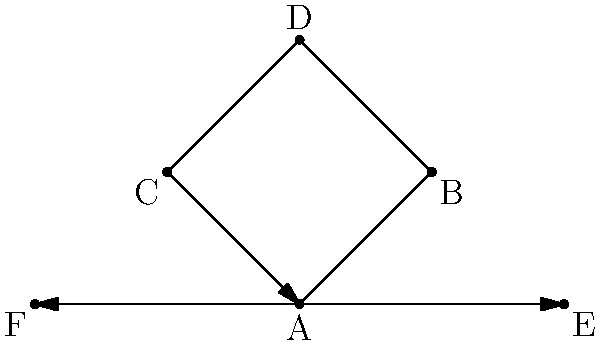After a merger between two companies, the new organizational structure is represented by the Cayley graph shown above. If the generating set consists of three operations (promotion, lateral transfer, and demotion), what is the order of the group represented by this Cayley graph? To determine the order of the group represented by this Cayley graph, we need to follow these steps:

1. Identify the number of vertices: The graph has 6 vertices (A, B, C, D, E, and F).

2. Understand the Cayley graph properties:
   - Each vertex represents an element of the group.
   - Each edge represents the action of a generator on a group element.

3. Analyze the graph structure:
   - The graph forms a cycle A-B-D-C-A, with two additional elements E and F connected to A.
   - This structure suggests that the group has a cyclic subgroup of order 4 (A, B, D, C) and two additional elements.

4. Consider the generating set:
   - The three operations (promotion, lateral transfer, and demotion) correspond to the three types of edges in the graph.
   - These operations allow movement between all elements of the group.

5. Determine the group order:
   - The order of a group is equal to the number of elements in the group.
   - In a Cayley graph, each vertex represents a unique element of the group.
   - Therefore, the order of the group is equal to the number of vertices in the Cayley graph.

6. Conclude:
   - The Cayley graph has 6 vertices.
   - Thus, the order of the group represented by this Cayley graph is 6.

This group structure could represent the possible positions an employee can hold within the merged company, with the generating set representing the possible ways to move between positions.
Answer: 6 